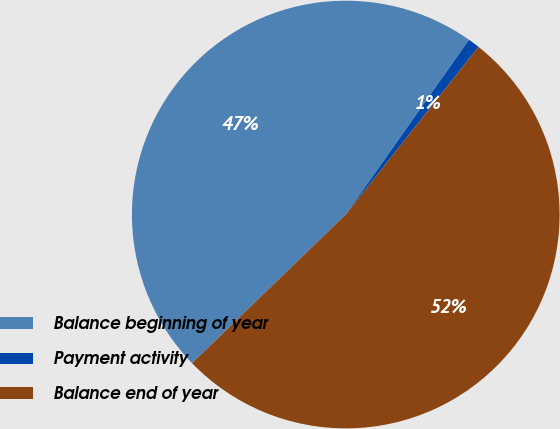Convert chart to OTSL. <chart><loc_0><loc_0><loc_500><loc_500><pie_chart><fcel>Balance beginning of year<fcel>Payment activity<fcel>Balance end of year<nl><fcel>47.01%<fcel>0.88%<fcel>52.11%<nl></chart> 